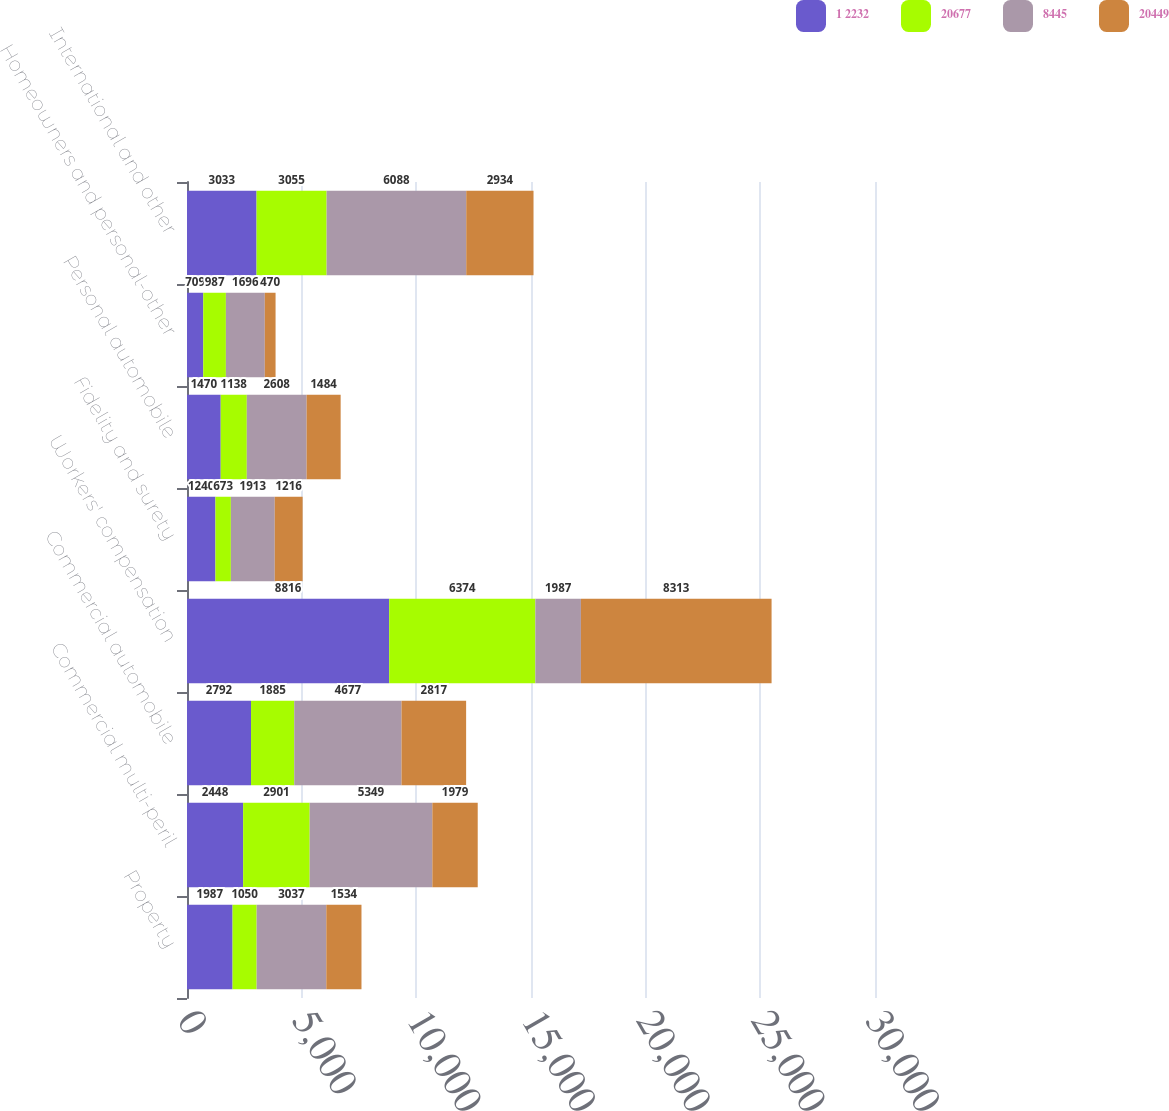<chart> <loc_0><loc_0><loc_500><loc_500><stacked_bar_chart><ecel><fcel>Property<fcel>Commercial multi-peril<fcel>Commercial automobile<fcel>Workers' compensation<fcel>Fidelity and surety<fcel>Personal automobile<fcel>Homeowners and personal-other<fcel>International and other<nl><fcel>1 2232<fcel>1987<fcel>2448<fcel>2792<fcel>8816<fcel>1240<fcel>1470<fcel>709<fcel>3033<nl><fcel>20677<fcel>1050<fcel>2901<fcel>1885<fcel>6374<fcel>673<fcel>1138<fcel>987<fcel>3055<nl><fcel>8445<fcel>3037<fcel>5349<fcel>4677<fcel>1987<fcel>1913<fcel>2608<fcel>1696<fcel>6088<nl><fcel>20449<fcel>1534<fcel>1979<fcel>2817<fcel>8313<fcel>1216<fcel>1484<fcel>470<fcel>2934<nl></chart> 